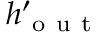<formula> <loc_0><loc_0><loc_500><loc_500>h _ { o u t } ^ { \prime }</formula> 